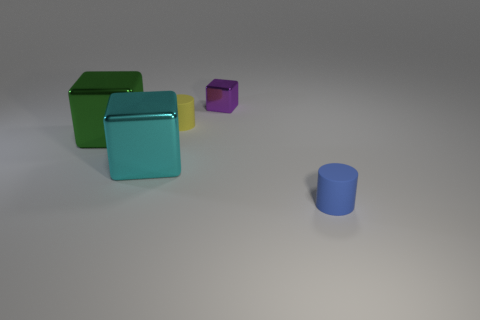Add 2 small yellow matte cylinders. How many objects exist? 7 Subtract all big shiny cubes. How many cubes are left? 1 Subtract all blue cylinders. How many cylinders are left? 1 Subtract 1 cubes. How many cubes are left? 2 Add 5 tiny brown matte cylinders. How many tiny brown matte cylinders exist? 5 Subtract 0 green cylinders. How many objects are left? 5 Subtract all cylinders. How many objects are left? 3 Subtract all red blocks. Subtract all yellow balls. How many blocks are left? 3 Subtract all large brown metallic blocks. Subtract all purple metal things. How many objects are left? 4 Add 4 small blue rubber objects. How many small blue rubber objects are left? 5 